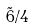Convert formula to latex. <formula><loc_0><loc_0><loc_500><loc_500>\tilde { 6 } / 4</formula> 